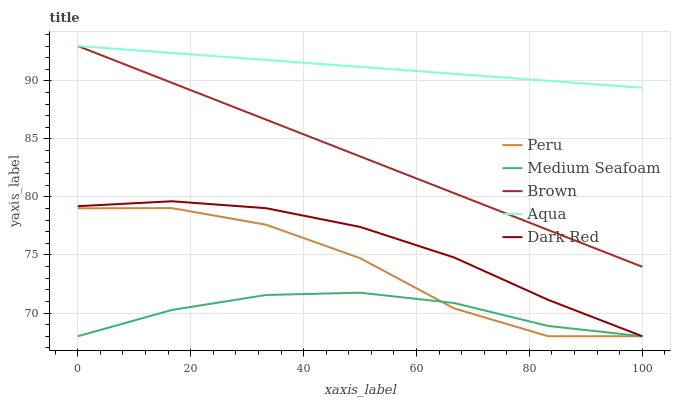Does Medium Seafoam have the minimum area under the curve?
Answer yes or no. Yes. Does Aqua have the maximum area under the curve?
Answer yes or no. Yes. Does Aqua have the minimum area under the curve?
Answer yes or no. No. Does Medium Seafoam have the maximum area under the curve?
Answer yes or no. No. Is Brown the smoothest?
Answer yes or no. Yes. Is Peru the roughest?
Answer yes or no. Yes. Is Aqua the smoothest?
Answer yes or no. No. Is Aqua the roughest?
Answer yes or no. No. Does Medium Seafoam have the lowest value?
Answer yes or no. Yes. Does Aqua have the lowest value?
Answer yes or no. No. Does Aqua have the highest value?
Answer yes or no. Yes. Does Medium Seafoam have the highest value?
Answer yes or no. No. Is Dark Red less than Brown?
Answer yes or no. Yes. Is Aqua greater than Dark Red?
Answer yes or no. Yes. Does Dark Red intersect Peru?
Answer yes or no. Yes. Is Dark Red less than Peru?
Answer yes or no. No. Is Dark Red greater than Peru?
Answer yes or no. No. Does Dark Red intersect Brown?
Answer yes or no. No. 